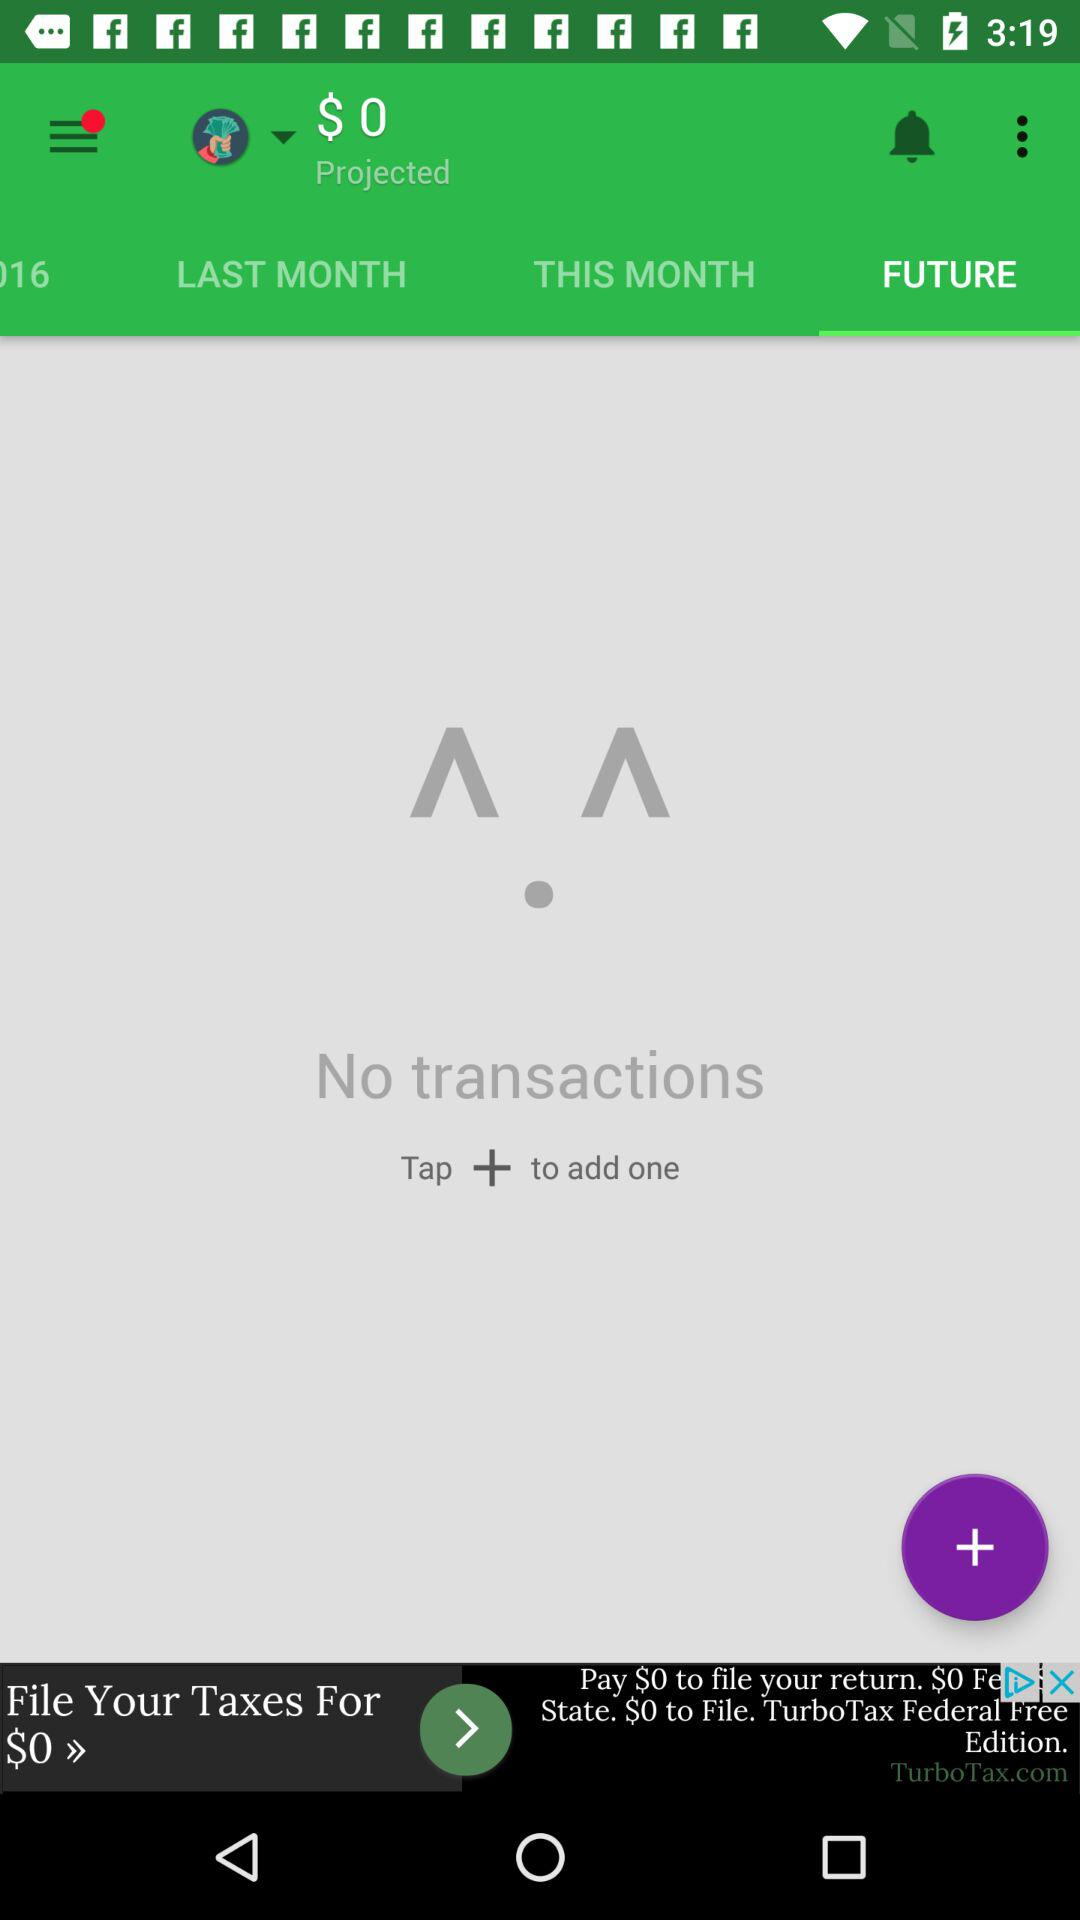How many transactions are there?
Answer the question using a single word or phrase. 0 